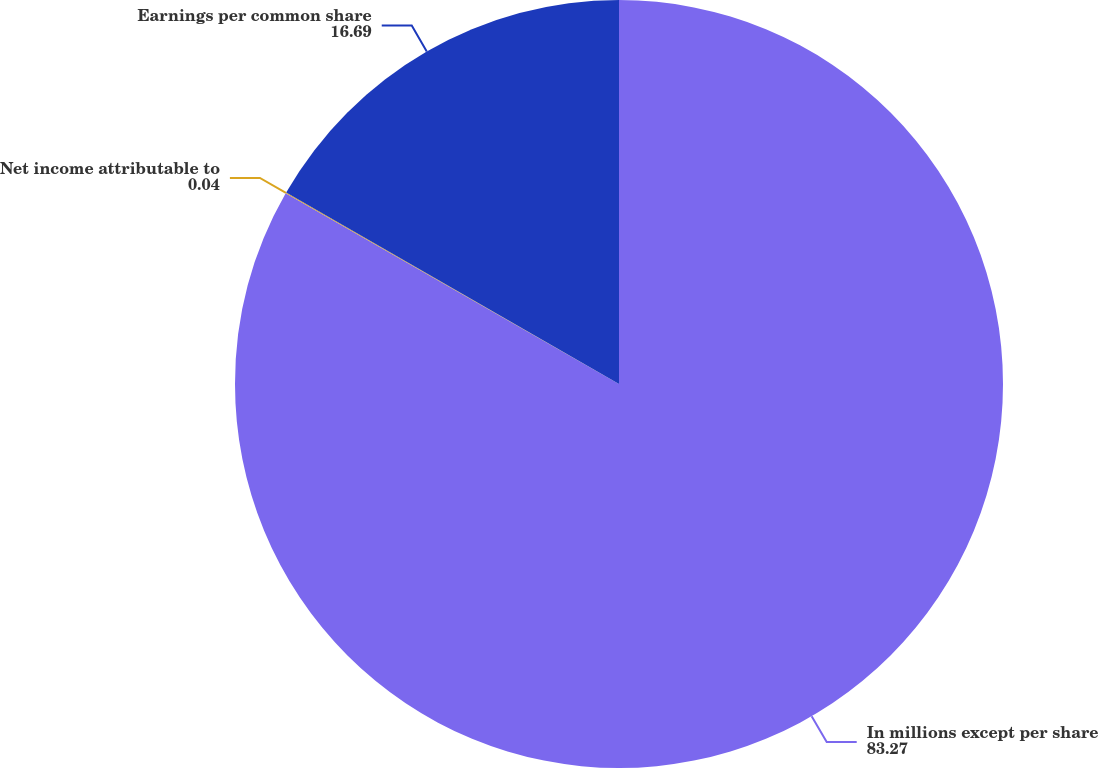Convert chart to OTSL. <chart><loc_0><loc_0><loc_500><loc_500><pie_chart><fcel>In millions except per share<fcel>Net income attributable to<fcel>Earnings per common share<nl><fcel>83.27%<fcel>0.04%<fcel>16.69%<nl></chart> 